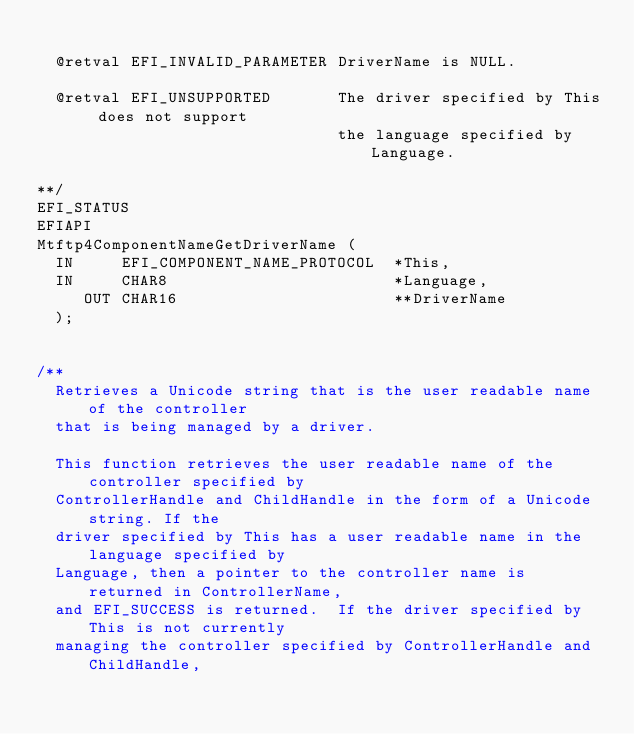Convert code to text. <code><loc_0><loc_0><loc_500><loc_500><_C_>
  @retval EFI_INVALID_PARAMETER DriverName is NULL.

  @retval EFI_UNSUPPORTED       The driver specified by This does not support
                                the language specified by Language.

**/
EFI_STATUS
EFIAPI
Mtftp4ComponentNameGetDriverName (
  IN     EFI_COMPONENT_NAME_PROTOCOL  *This,
  IN     CHAR8                        *Language,
     OUT CHAR16                       **DriverName
  );


/**
  Retrieves a Unicode string that is the user readable name of the controller
  that is being managed by a driver.

  This function retrieves the user readable name of the controller specified by
  ControllerHandle and ChildHandle in the form of a Unicode string. If the
  driver specified by This has a user readable name in the language specified by
  Language, then a pointer to the controller name is returned in ControllerName,
  and EFI_SUCCESS is returned.  If the driver specified by This is not currently
  managing the controller specified by ControllerHandle and ChildHandle,</code> 